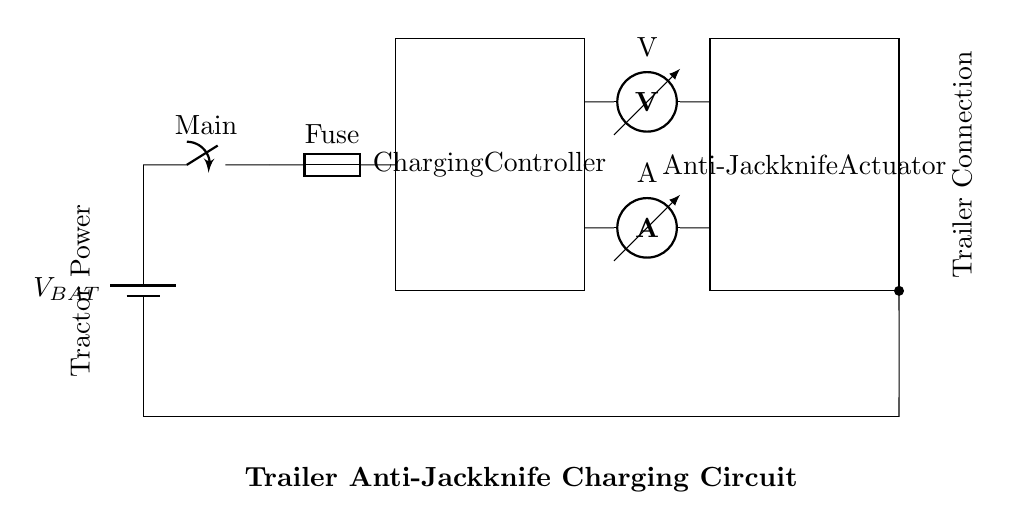What is the type of power source in this circuit? The circuit diagram shows a battery labeled as V_BAT. This indicates that a battery is the power source providing voltage to the rest of the circuit.
Answer: Battery What component regulates the charging process? The circuit includes a rectangular box labeled as Charging Controller, indicating that this component controls and regulates the charging process for the anti-jackknife system.
Answer: Charging Controller How many sensors are present in the circuit? There are two sensors depicted in the circuit: a voltmeter and an ammeter. These devices monitor voltage and current, respectively.
Answer: Two What does the switch control in this circuit? The switch labeled Main allows for the control of the circuit's power by enabling or disabling the connection to the battery, thus controlling the current flow in the circuit.
Answer: Circuit power Which component is located at the end of the circuit? The last component on the circuit diagram is labeled Anti-Jackknife Actuator. This indicates it is the actuator responsible for executing commands based on the charging controller's outputs.
Answer: Anti-Jackknife Actuator What is the function of the fuse in the circuit? The fuse serves as a safety device that protects the circuit from excessive current by blowing (or breaking the circuit) if the current surpasses a certain threshold. This ensures the circuit remains safe during operation.
Answer: Safety device What is the role of the trailer connection in the circuit? The circuit diagram indicates a connection labeled Trailer Connection, which implies that this connection is crucial for linking the trailer's electrical components to the tractor's power and control systems.
Answer: Trailer link 